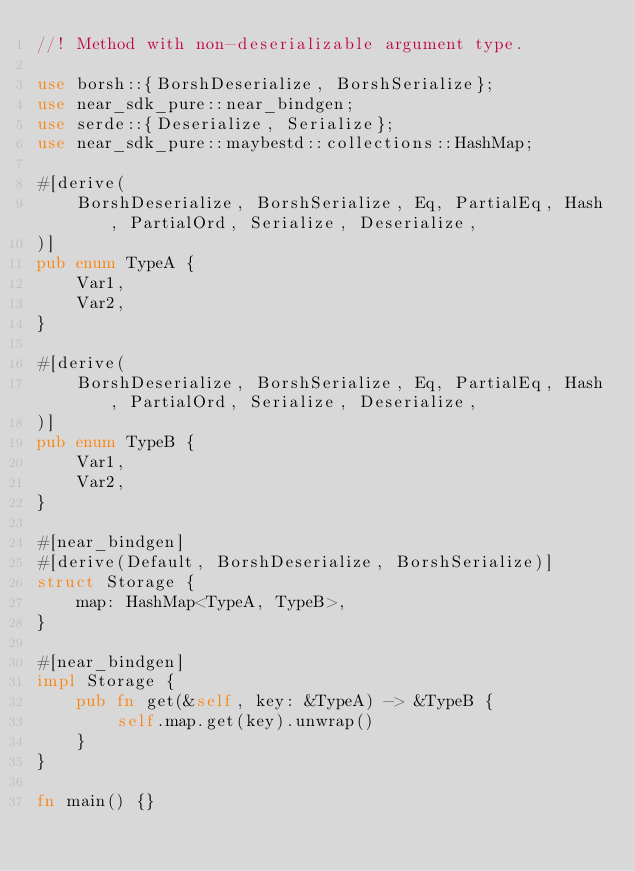<code> <loc_0><loc_0><loc_500><loc_500><_Rust_>//! Method with non-deserializable argument type.

use borsh::{BorshDeserialize, BorshSerialize};
use near_sdk_pure::near_bindgen;
use serde::{Deserialize, Serialize};
use near_sdk_pure::maybestd::collections::HashMap;

#[derive(
    BorshDeserialize, BorshSerialize, Eq, PartialEq, Hash, PartialOrd, Serialize, Deserialize,
)]
pub enum TypeA {
    Var1,
    Var2,
}

#[derive(
    BorshDeserialize, BorshSerialize, Eq, PartialEq, Hash, PartialOrd, Serialize, Deserialize,
)]
pub enum TypeB {
    Var1,
    Var2,
}

#[near_bindgen]
#[derive(Default, BorshDeserialize, BorshSerialize)]
struct Storage {
    map: HashMap<TypeA, TypeB>,
}

#[near_bindgen]
impl Storage {
    pub fn get(&self, key: &TypeA) -> &TypeB {
        self.map.get(key).unwrap()
    }
}

fn main() {}
</code> 